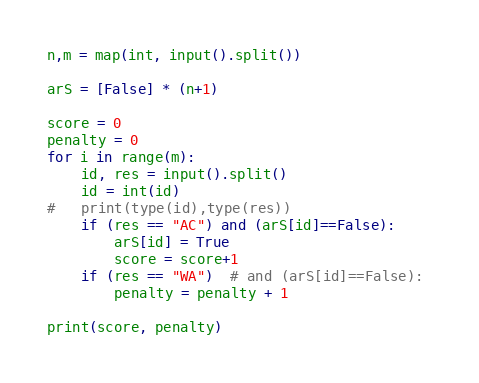<code> <loc_0><loc_0><loc_500><loc_500><_Python_>n,m = map(int, input().split())
 
arS = [False] * (n+1)
 
score = 0
penalty = 0
for i in range(m):
	id, res = input().split()
	id = int(id)
#	print(type(id),type(res))
	if (res == "AC") and (arS[id]==False):
		arS[id] = True
		score = score+1
	if (res == "WA")  # and (arS[id]==False): 
		penalty = penalty + 1
        
print(score, penalty)</code> 